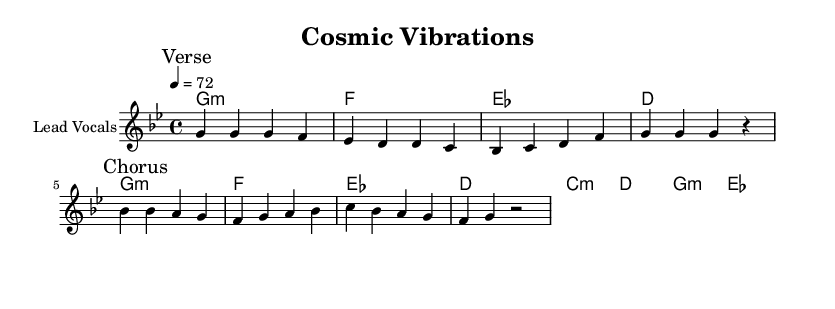What is the key signature of this music? The key signature is G minor, which contains two flats (B flat and E flat). This is indicated at the beginning of the staff.
Answer: G minor What is the time signature of this music? The time signature is 4/4, meaning there are four beats in each measure, and a quarter note receives one beat. This is shown at the beginning of the score.
Answer: 4/4 What is the tempo marking of the piece? The tempo marking is 4 equals 72, which indicates that there are 72 quarter note beats per minute. This is noted at the beginning of the score.
Answer: 72 How many measures are in the verse section? The verse section consists of four measures as indicated by the markings in the melody section. The measures are grouped and counted until the break.
Answer: 4 What is the main theme of the chorus? The main theme of the chorus emphasizes unity and interconnectedness, as expressed in the lyrics. The simplicity of the lyrics conveys a deep message of oneness in the universe.
Answer: Uniqueness Which chord appears first in the harmony section? The first chord in the harmony section is G minor, as indicated at the beginning of the chord sequence.
Answer: G minor What type of reggae style is reflected in the rhythm of the melody? The rhythm of the melody is reflective of "Roots reggae," which typically emphasizes a laid-back groove and highlights social consciousness themes. This is characteristically found in the rhythmic placement of the notes.
Answer: Roots reggae 